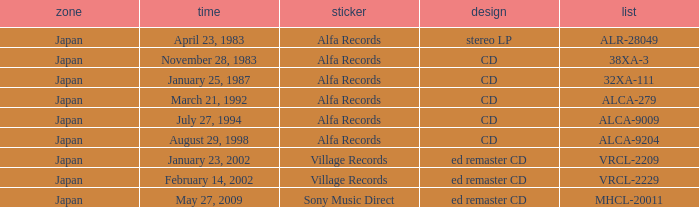Which catalog is in cd format? 38XA-3, 32XA-111, ALCA-279, ALCA-9009, ALCA-9204. 